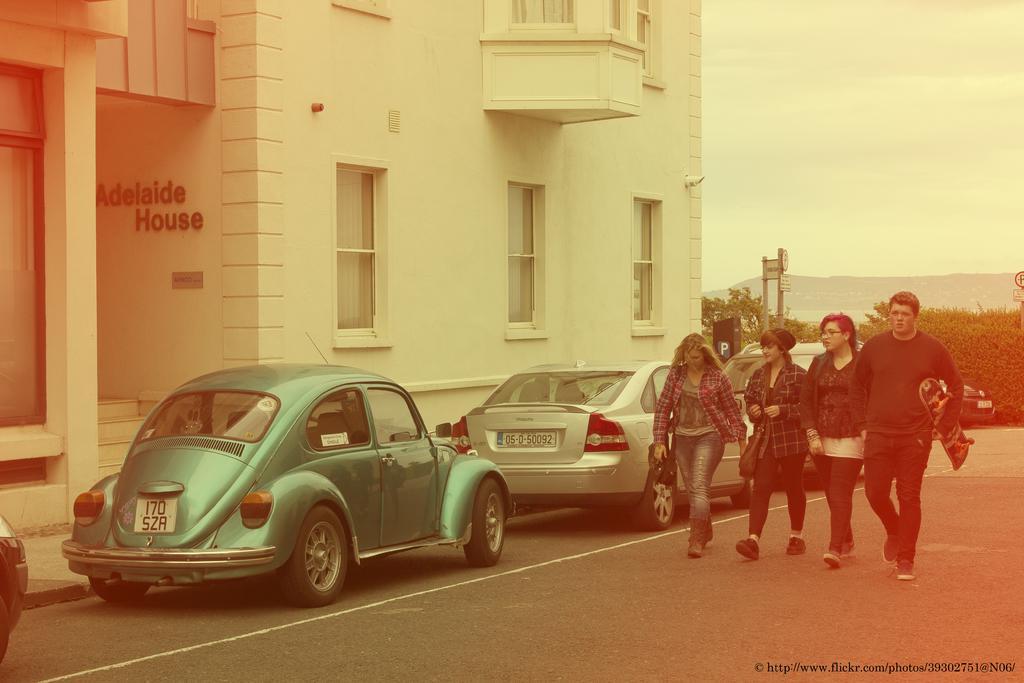Describe this image in one or two sentences. In this image I see 3 women and a man and I see that this man is holding a skateboard in his hand and I see the road on which there is a white line and I see few cars and I see the watermark over here. In the background I see a building and I see 2 words written over here on this wall and I see the steps over here and I see number of trees, a sign board and the clear sky. 